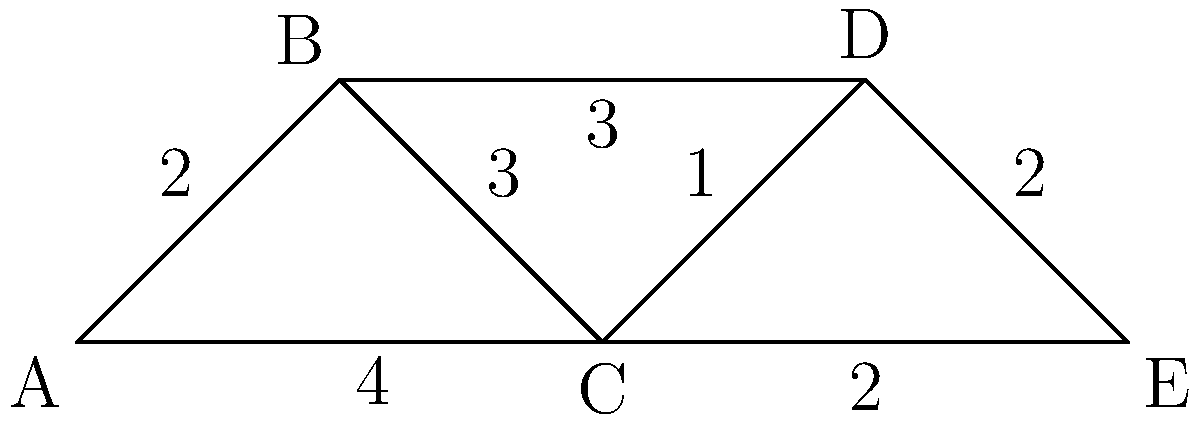As a dedicated Feralpisalò fan, you're planning routes to the stadium. The graph represents different paths, where vertices are locations and edge weights are distances in kilometers. What's the minimum number of edges that need to be removed to disconnect the stadium (vertex E) from the starting point (vertex A)? To solve this problem, we need to find the minimum cut between vertices A and E. Here's the step-by-step process:

1) First, identify all possible paths from A to E:
   - A -> B -> C -> D -> E
   - A -> B -> D -> E
   - A -> C -> D -> E
   - A -> C -> E

2) Now, we need to find the minimum number of edges that, when removed, will disconnect all these paths.

3) Observe that all paths must go through either B or C to reach E.

4) If we remove the edges C-E and B-D, we disconnect all paths from A to E:
   - A -> B -> C -> D -> E (blocked at B-D)
   - A -> B -> D -> E (blocked at B-D)
   - A -> C -> D -> E (blocked at C-E)
   - A -> C -> E (blocked at C-E)

5) No single edge removal can disconnect all paths, so the minimum number of edges to remove is 2.

6) This is known as the min-cut or the edge connectivity between A and E in graph theory.
Answer: 2 